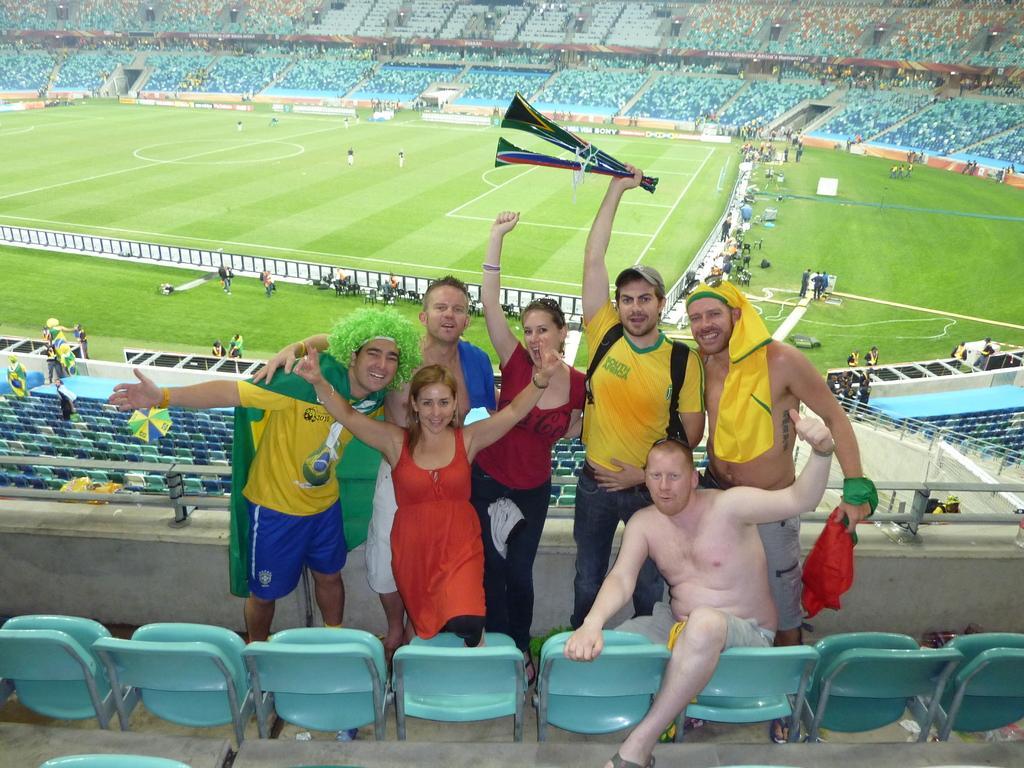How would you summarize this image in a sentence or two? It is looking like stadium. In the middle of the image there is aground few people are playing in that. On the bottom of the image I can see few people are standing, smiling and giving pose to the picture. 